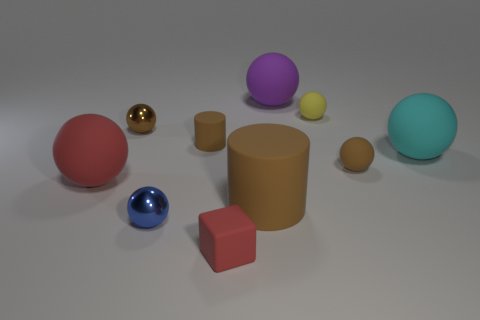What number of objects are either rubber cubes or balls that are in front of the brown shiny ball?
Keep it short and to the point. 5. There is a blue ball that is the same size as the yellow thing; what material is it?
Your answer should be very brief. Metal. Is the cyan object made of the same material as the red ball?
Your answer should be compact. Yes. There is a big rubber sphere that is both in front of the large purple thing and to the right of the blue sphere; what color is it?
Give a very brief answer. Cyan. There is a big matte sphere in front of the cyan rubber thing; is its color the same as the matte block?
Ensure brevity in your answer.  Yes. There is a purple matte thing that is the same size as the cyan ball; what shape is it?
Make the answer very short. Sphere. How many other objects are the same color as the tiny cylinder?
Offer a terse response. 3. How many other objects are there of the same material as the large cylinder?
Ensure brevity in your answer.  7. There is a red matte cube; does it have the same size as the brown ball that is left of the small red matte cube?
Keep it short and to the point. Yes. What is the color of the large rubber cylinder?
Your answer should be very brief. Brown. 